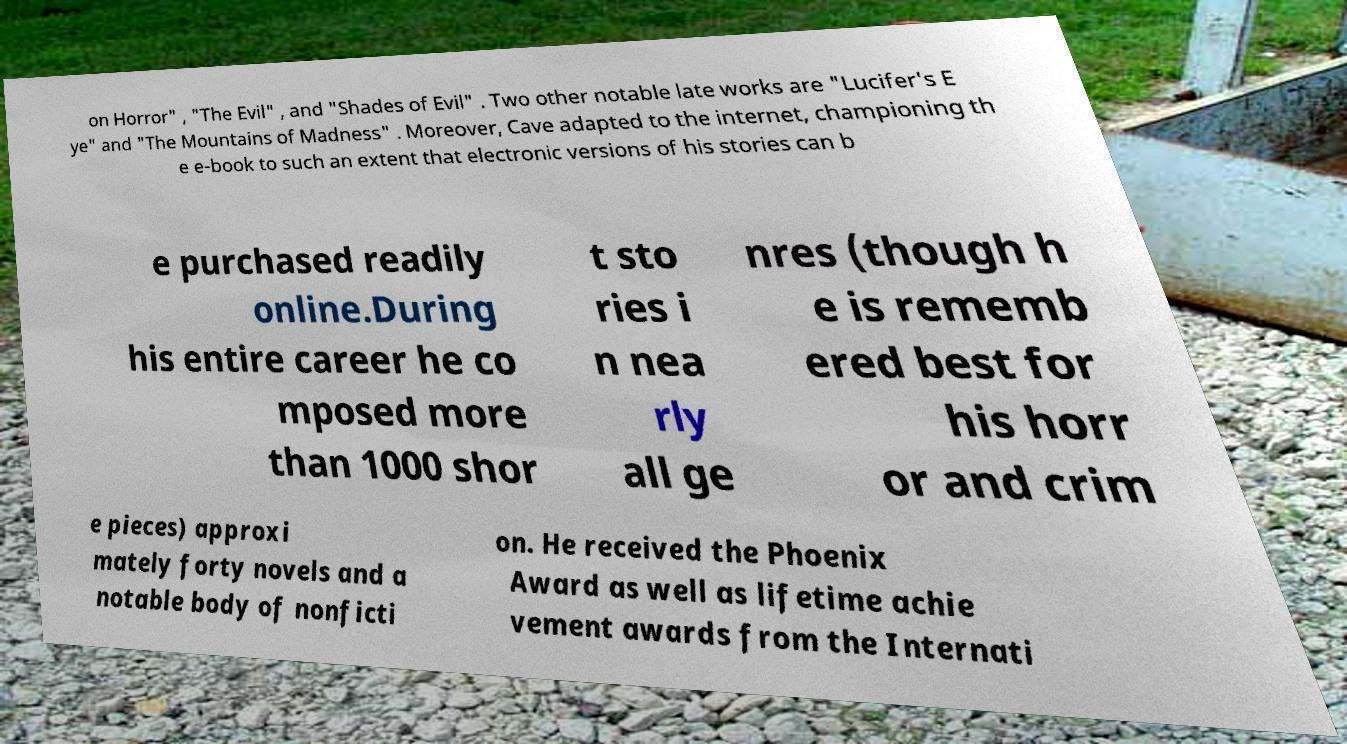Please identify and transcribe the text found in this image. on Horror" , "The Evil" , and "Shades of Evil" . Two other notable late works are "Lucifer's E ye" and "The Mountains of Madness" . Moreover, Cave adapted to the internet, championing th e e-book to such an extent that electronic versions of his stories can b e purchased readily online.During his entire career he co mposed more than 1000 shor t sto ries i n nea rly all ge nres (though h e is rememb ered best for his horr or and crim e pieces) approxi mately forty novels and a notable body of nonficti on. He received the Phoenix Award as well as lifetime achie vement awards from the Internati 